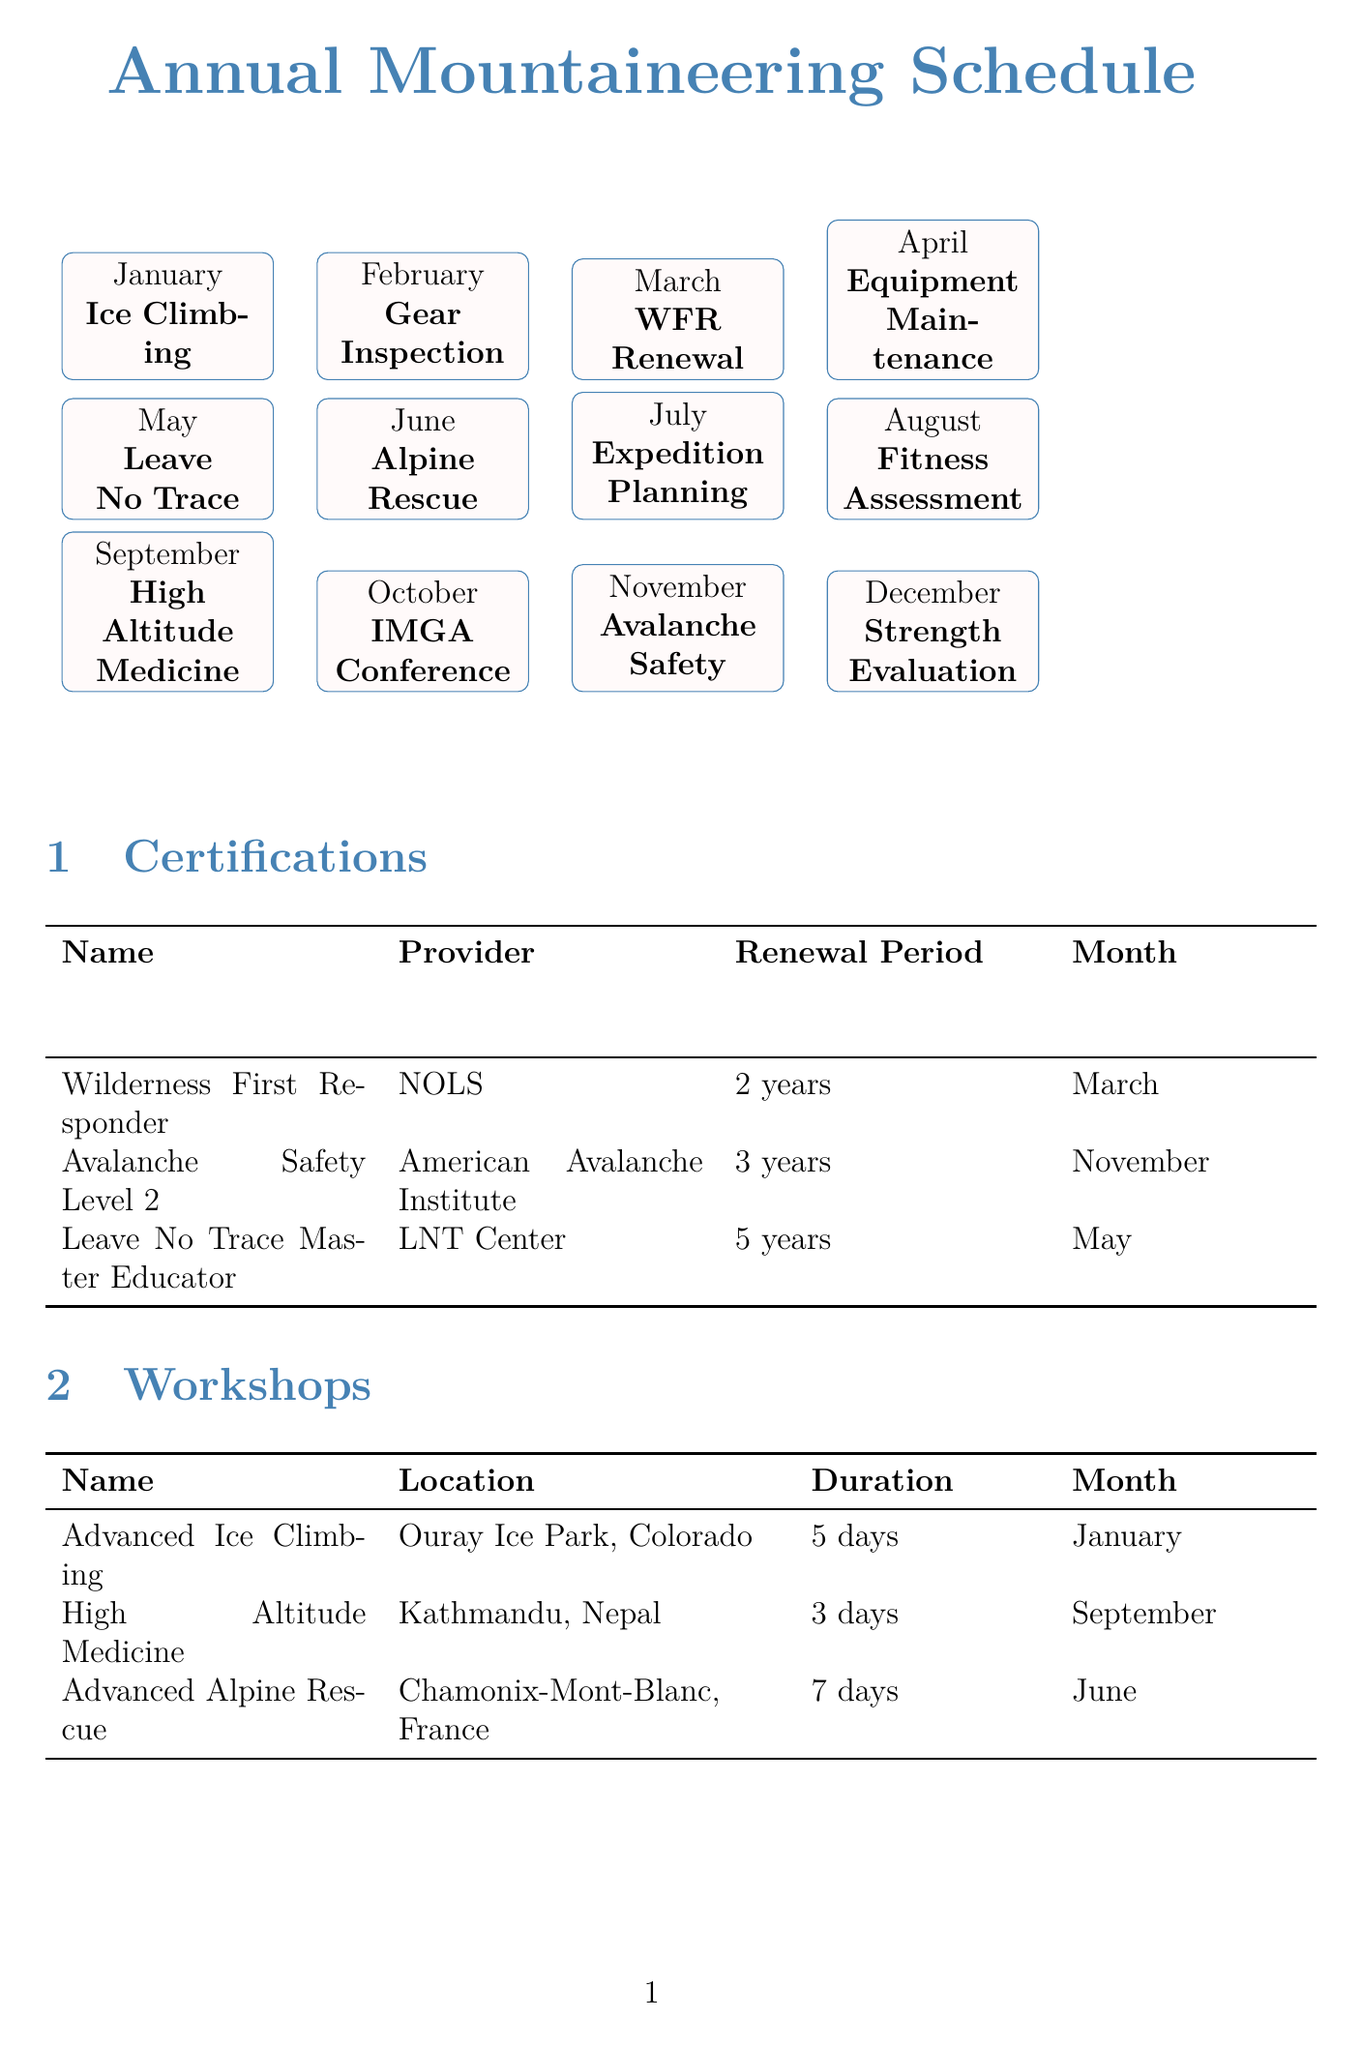What is the recommended month for the Wilderness First Responder certification? The document states that the recommended month for the Wilderness First Responder certification is March.
Answer: March How long is the Advanced Ice Climbing Techniques workshop? According to the document, the duration of the Advanced Ice Climbing Techniques workshop is 5 days.
Answer: 5 days What items are checked during the Annual Gear Inspection? The document lists the items checked during the Annual Gear Inspection as ropes, harnesses, carabiners, helmets, and crampons.
Answer: Ropes, harnesses, carabiners, helmets, crampons Which certification has a renewal period of 3 years? The document indicates that the Avalanche Safety Level 2 certification has a renewal period of 3 years.
Answer: Avalanche Safety Level 2 When is the Cardiovascular Endurance Assessment scheduled? The document notes that the Cardiovascular Endurance Assessment is recommended for August.
Answer: August What are the activities included in Annual Expedition Goal Setting? The document specifies the activities included in Annual Expedition Goal Setting as reviewing past expeditions, setting new objectives, and planning training.
Answer: Review past expeditions, set new objectives, plan training Which month is dedicated to Strength and Flexibility Evaluation? It is indicated in the document that the month dedicated to Strength and Flexibility Evaluation is December.
Answer: December How many days does the High Altitude Medicine Symposium last? According to the document, the High Altitude Medicine Symposium lasts for 3 days.
Answer: 3 days What are the recommended months for Seasonal Equipment Maintenance? The document states that Seasonal Equipment Maintenance is recommended for April and October.
Answer: April, October 